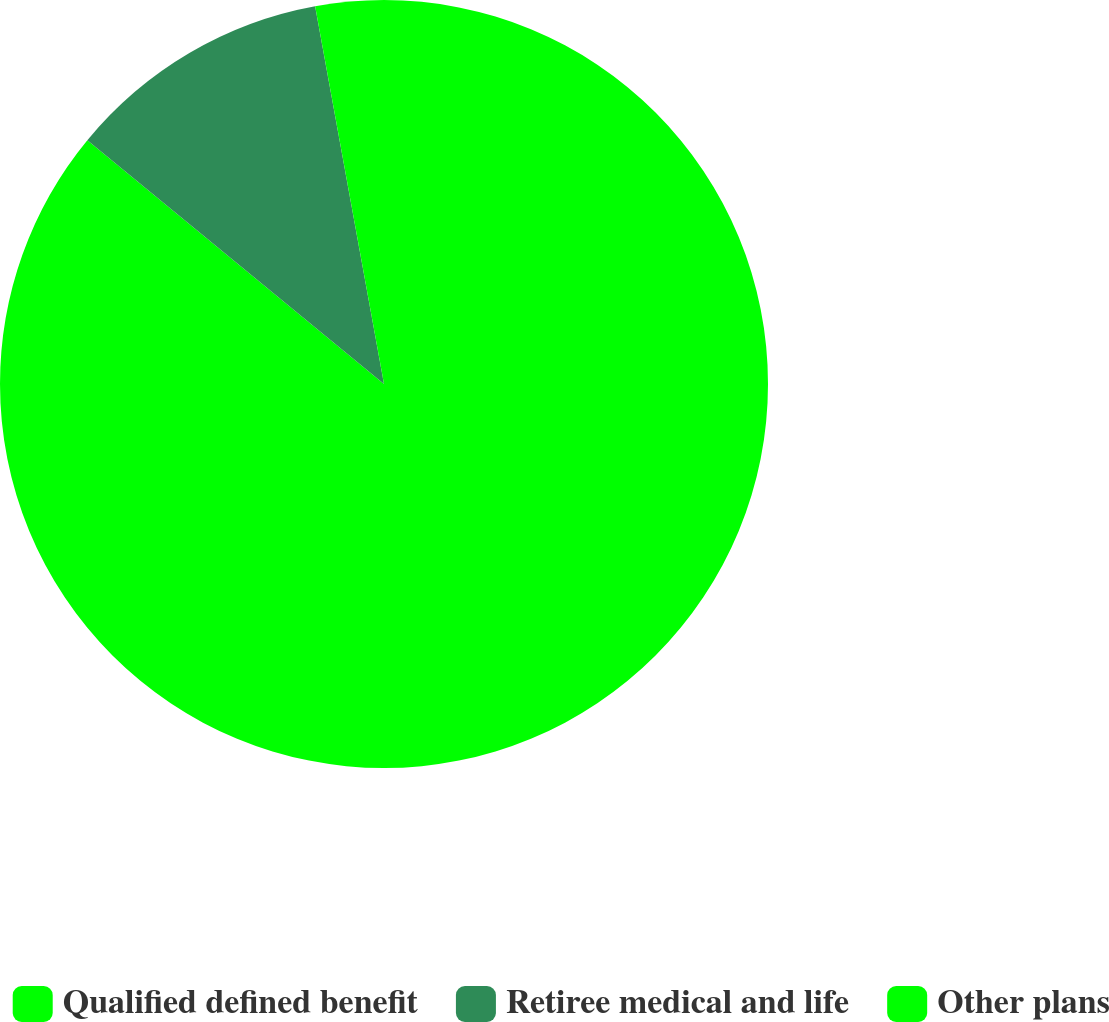Convert chart. <chart><loc_0><loc_0><loc_500><loc_500><pie_chart><fcel>Qualified defined benefit<fcel>Retiree medical and life<fcel>Other plans<nl><fcel>85.95%<fcel>11.18%<fcel>2.87%<nl></chart> 